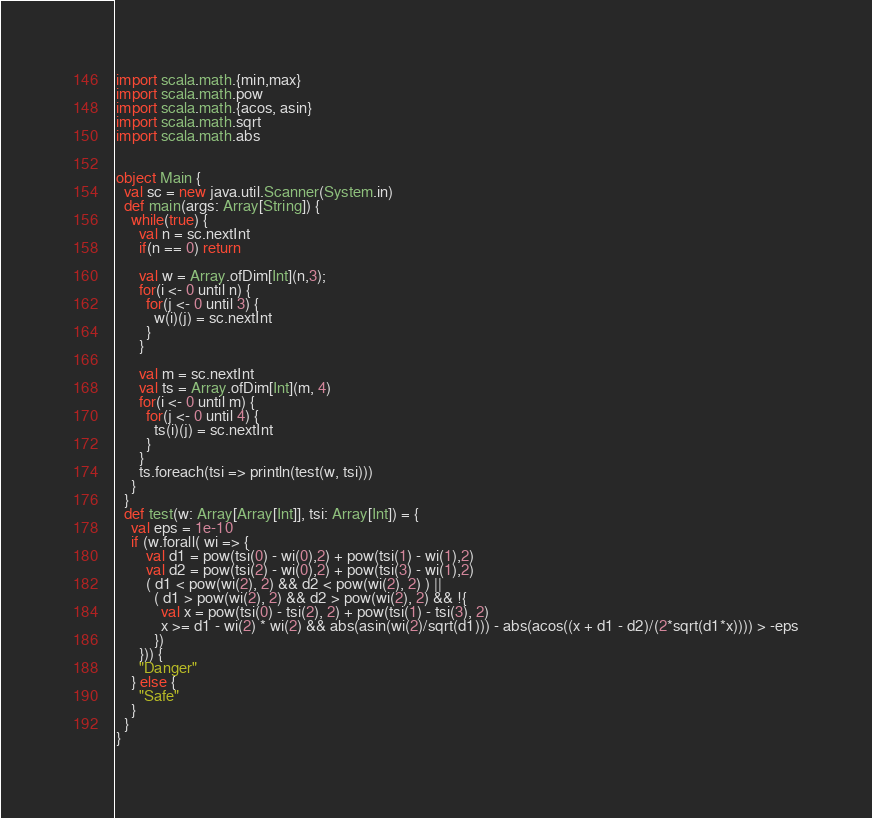<code> <loc_0><loc_0><loc_500><loc_500><_Scala_>import scala.math.{min,max}
import scala.math.pow
import scala.math.{acos, asin}
import scala.math.sqrt
import scala.math.abs


object Main {
  val sc = new java.util.Scanner(System.in)
  def main(args: Array[String]) {
    while(true) {
      val n = sc.nextInt
      if(n == 0) return

      val w = Array.ofDim[Int](n,3);
      for(i <- 0 until n) {
        for(j <- 0 until 3) {
          w(i)(j) = sc.nextInt
        }
      }

      val m = sc.nextInt
      val ts = Array.ofDim[Int](m, 4)
      for(i <- 0 until m) {
        for(j <- 0 until 4) {
          ts(i)(j) = sc.nextInt
        }
      }
      ts.foreach(tsi => println(test(w, tsi)))
    }
  }
  def test(w: Array[Array[Int]], tsi: Array[Int]) = {
    val eps = 1e-10
    if (w.forall( wi => {
        val d1 = pow(tsi(0) - wi(0),2) + pow(tsi(1) - wi(1),2)
        val d2 = pow(tsi(2) - wi(0),2) + pow(tsi(3) - wi(1),2)
        ( d1 < pow(wi(2), 2) && d2 < pow(wi(2), 2) ) ||
          ( d1 > pow(wi(2), 2) && d2 > pow(wi(2), 2) && !{
            val x = pow(tsi(0) - tsi(2), 2) + pow(tsi(1) - tsi(3), 2)
            x >= d1 - wi(2) * wi(2) && abs(asin(wi(2)/sqrt(d1))) - abs(acos((x + d1 - d2)/(2*sqrt(d1*x)))) > -eps
          })
      })) {
      "Danger"
    } else {
      "Safe"
    }
  }
}</code> 